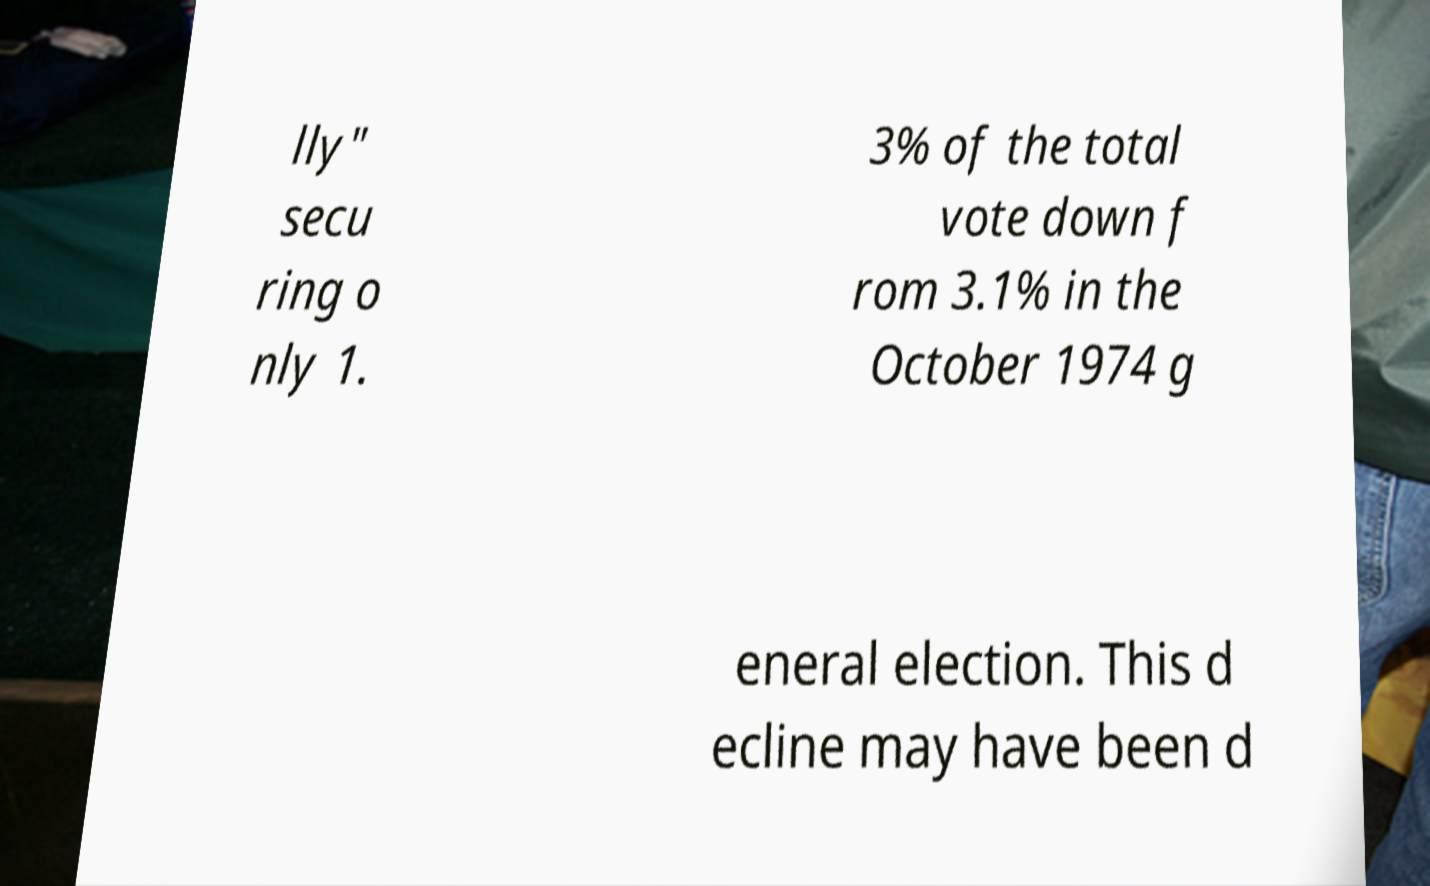Could you assist in decoding the text presented in this image and type it out clearly? lly" secu ring o nly 1. 3% of the total vote down f rom 3.1% in the October 1974 g eneral election. This d ecline may have been d 